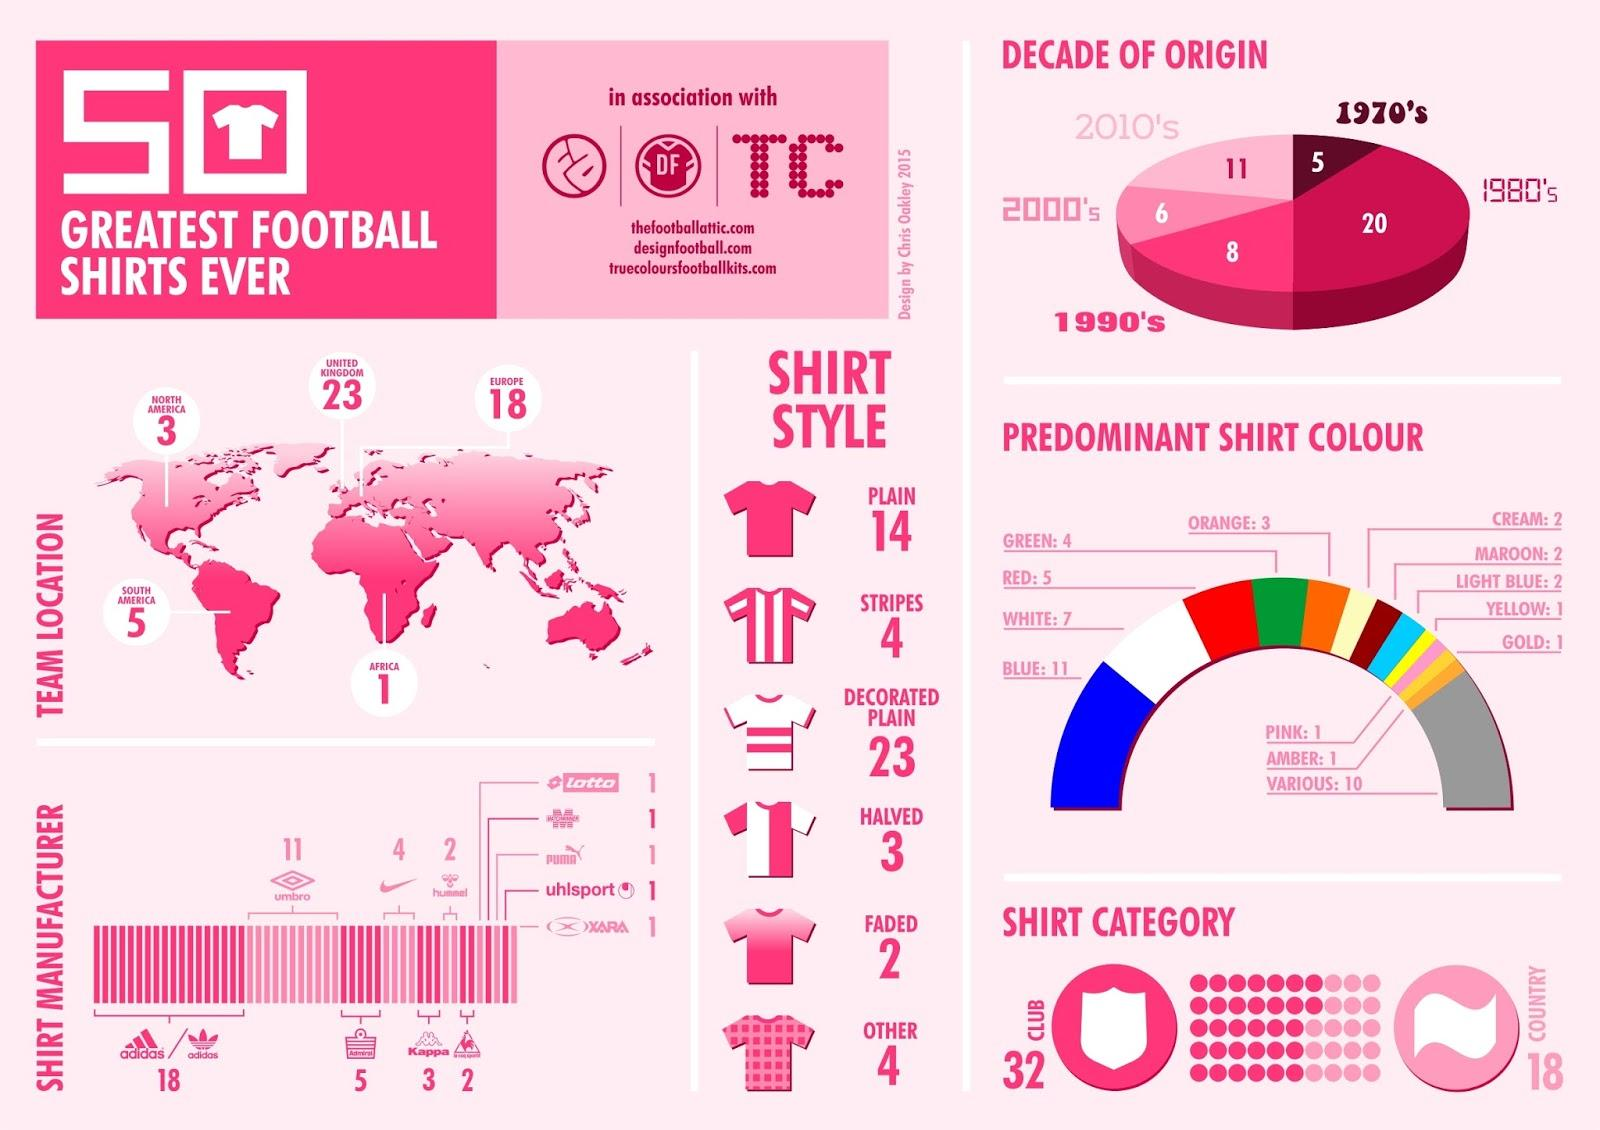Specify some key components in this picture. There are three team locations in North America. The fourth predominant shirt color is red. The third most prevalent shirt color is white. There are five locations of teams in South America. There is only one team location in Africa. 